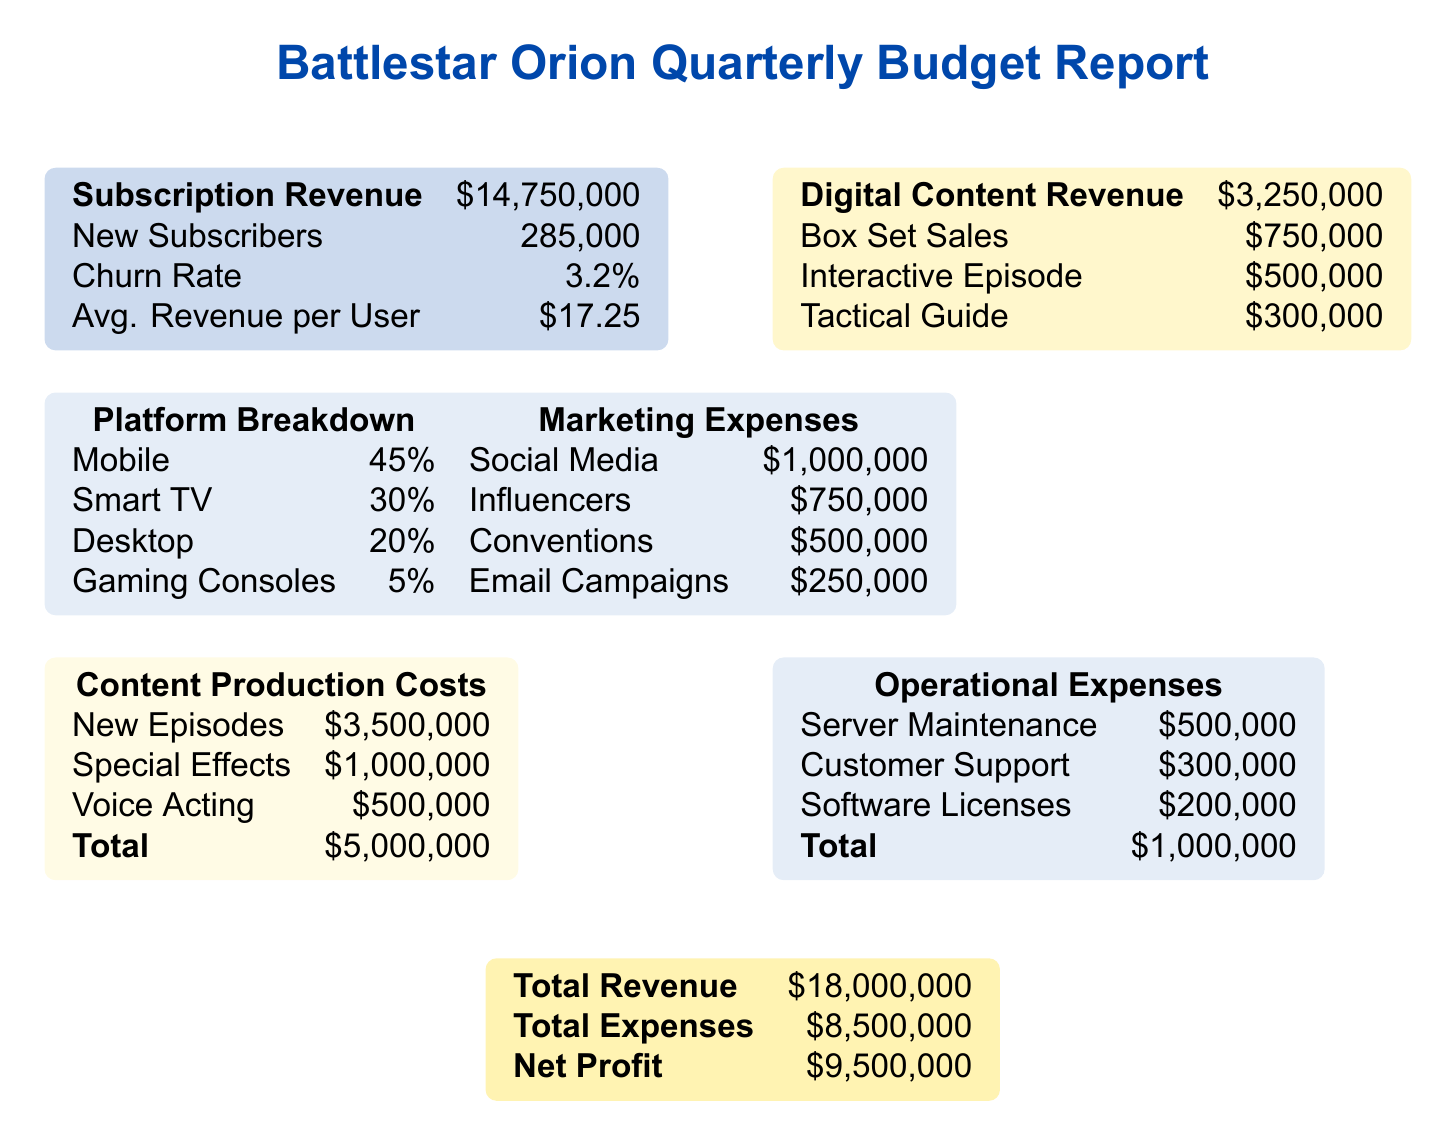what is the total revenue? The total revenue is noted at the bottom of the document, summarizing all income sources, which is $14,750,000 from subscriptions and $3,250,000 from digital content, totaling $18,000,000.
Answer: $18,000,000 what is the churn rate? The churn rate is provided in the section detailing subscription information, indicating the percentage of subscribers lost over the quarter, which is 3.2%.
Answer: 3.2% how much was spent on content production? The document specifies content production costs, which include new episodes and special effects, totaling $5,000,000.
Answer: $5,000,000 what percentage of revenue came from subscriptions? To find the percentage, compare the subscription revenue of $14,750,000 against the total revenue of $18,000,000, resulting in approximately 81.94%.
Answer: 81.94% how many new subscribers did Battlestar Orion gain? The number of new subscribers is directly listed in the document under subscription data, which shows 285,000 new subscribers this quarter.
Answer: 285,000 what are the marketing expenses? The marketing expenses are broken down in the document, with different activities listed totaling $2,500,000.
Answer: $2,500,000 what is the net profit for the quarter? The net profit is calculated by subtracting total expenses from total revenue, which is $18,000,000 - $8,500,000 = $9,500,000.
Answer: $9,500,000 how much revenue was generated from box set sales? The revenue generated from box set sales is specified in the digital content section, amounting to $750,000.
Answer: $750,000 what is the percentage of subscription revenue relative to total revenue? This percentage can be found by comparing the subscription revenue of $14,750,000 against the total revenue of $18,000,000, giving approximately 81.94%.
Answer: 81.94% 